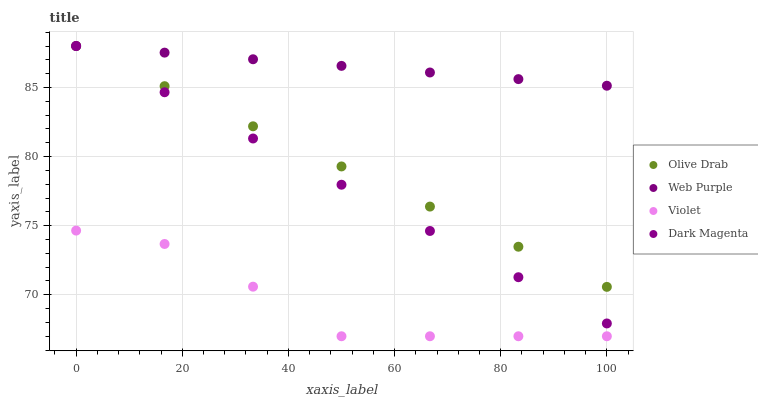Does Violet have the minimum area under the curve?
Answer yes or no. Yes. Does Web Purple have the maximum area under the curve?
Answer yes or no. Yes. Does Dark Magenta have the minimum area under the curve?
Answer yes or no. No. Does Dark Magenta have the maximum area under the curve?
Answer yes or no. No. Is Web Purple the smoothest?
Answer yes or no. Yes. Is Violet the roughest?
Answer yes or no. Yes. Is Dark Magenta the smoothest?
Answer yes or no. No. Is Dark Magenta the roughest?
Answer yes or no. No. Does Violet have the lowest value?
Answer yes or no. Yes. Does Dark Magenta have the lowest value?
Answer yes or no. No. Does Olive Drab have the highest value?
Answer yes or no. Yes. Does Violet have the highest value?
Answer yes or no. No. Is Violet less than Dark Magenta?
Answer yes or no. Yes. Is Dark Magenta greater than Violet?
Answer yes or no. Yes. Does Dark Magenta intersect Olive Drab?
Answer yes or no. Yes. Is Dark Magenta less than Olive Drab?
Answer yes or no. No. Is Dark Magenta greater than Olive Drab?
Answer yes or no. No. Does Violet intersect Dark Magenta?
Answer yes or no. No. 